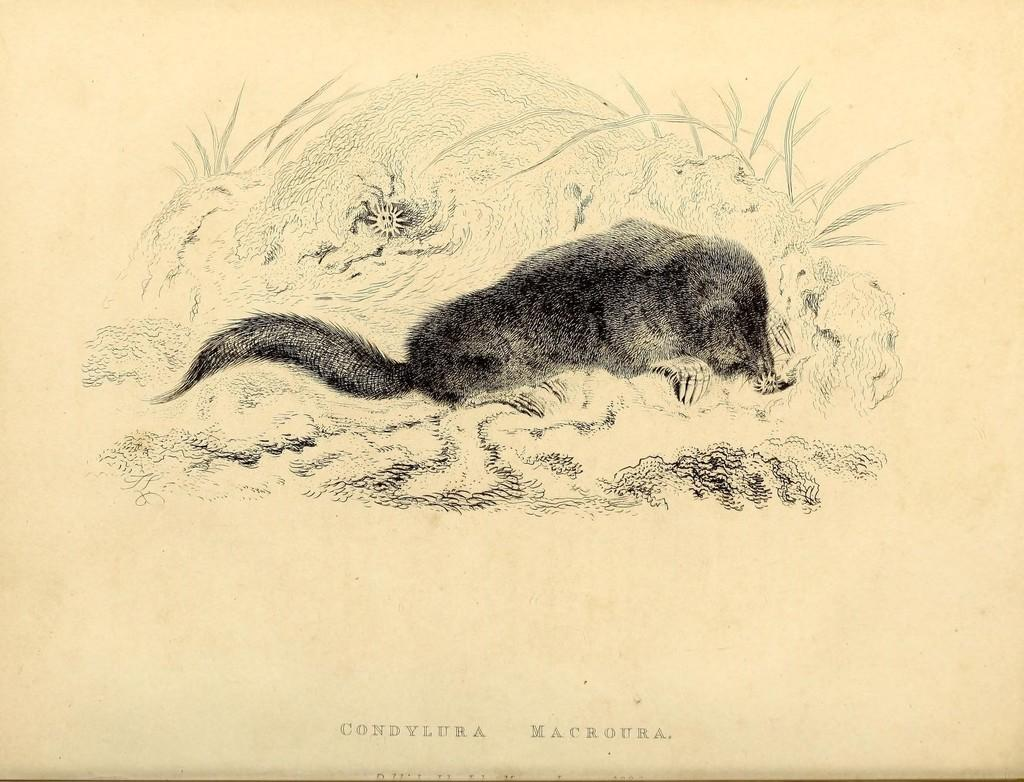What is the main subject of the image? The main subject of the image is a drawing. What type of animal is depicted in the drawing? The drawing contains an animal. Is there any text associated with the drawing? Yes, there is text at the bottom of the drawing. Where is the ornament located in the image? There is no ornament present in the image; it only contains a drawing with an animal and text at the bottom. 